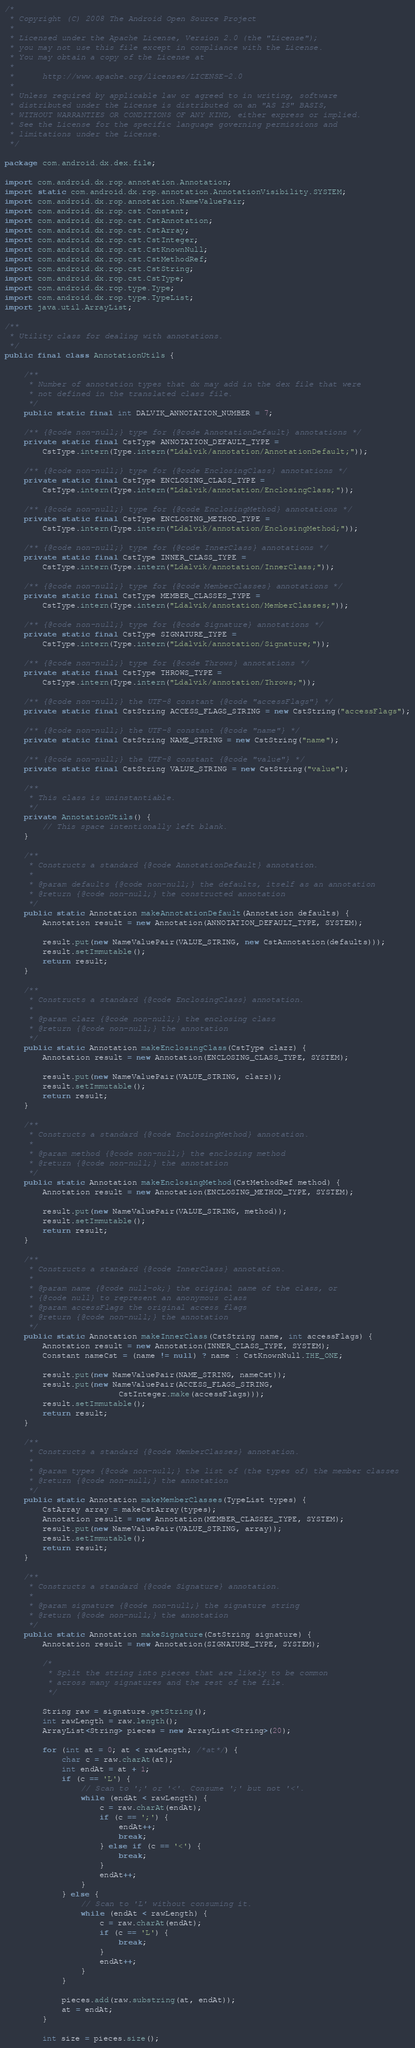Convert code to text. <code><loc_0><loc_0><loc_500><loc_500><_Java_>/*
 * Copyright (C) 2008 The Android Open Source Project
 *
 * Licensed under the Apache License, Version 2.0 (the "License");
 * you may not use this file except in compliance with the License.
 * You may obtain a copy of the License at
 *
 *      http://www.apache.org/licenses/LICENSE-2.0
 *
 * Unless required by applicable law or agreed to in writing, software
 * distributed under the License is distributed on an "AS IS" BASIS,
 * WITHOUT WARRANTIES OR CONDITIONS OF ANY KIND, either express or implied.
 * See the License for the specific language governing permissions and
 * limitations under the License.
 */

package com.android.dx.dex.file;

import com.android.dx.rop.annotation.Annotation;
import static com.android.dx.rop.annotation.AnnotationVisibility.SYSTEM;
import com.android.dx.rop.annotation.NameValuePair;
import com.android.dx.rop.cst.Constant;
import com.android.dx.rop.cst.CstAnnotation;
import com.android.dx.rop.cst.CstArray;
import com.android.dx.rop.cst.CstInteger;
import com.android.dx.rop.cst.CstKnownNull;
import com.android.dx.rop.cst.CstMethodRef;
import com.android.dx.rop.cst.CstString;
import com.android.dx.rop.cst.CstType;
import com.android.dx.rop.type.Type;
import com.android.dx.rop.type.TypeList;
import java.util.ArrayList;

/**
 * Utility class for dealing with annotations.
 */
public final class AnnotationUtils {

    /**
     * Number of annotation types that dx may add in the dex file that were
     * not defined in the translated class file.
     */
    public static final int DALVIK_ANNOTATION_NUMBER = 7;

    /** {@code non-null;} type for {@code AnnotationDefault} annotations */
    private static final CstType ANNOTATION_DEFAULT_TYPE =
        CstType.intern(Type.intern("Ldalvik/annotation/AnnotationDefault;"));

    /** {@code non-null;} type for {@code EnclosingClass} annotations */
    private static final CstType ENCLOSING_CLASS_TYPE =
        CstType.intern(Type.intern("Ldalvik/annotation/EnclosingClass;"));

    /** {@code non-null;} type for {@code EnclosingMethod} annotations */
    private static final CstType ENCLOSING_METHOD_TYPE =
        CstType.intern(Type.intern("Ldalvik/annotation/EnclosingMethod;"));

    /** {@code non-null;} type for {@code InnerClass} annotations */
    private static final CstType INNER_CLASS_TYPE =
        CstType.intern(Type.intern("Ldalvik/annotation/InnerClass;"));

    /** {@code non-null;} type for {@code MemberClasses} annotations */
    private static final CstType MEMBER_CLASSES_TYPE =
        CstType.intern(Type.intern("Ldalvik/annotation/MemberClasses;"));

    /** {@code non-null;} type for {@code Signature} annotations */
    private static final CstType SIGNATURE_TYPE =
        CstType.intern(Type.intern("Ldalvik/annotation/Signature;"));

    /** {@code non-null;} type for {@code Throws} annotations */
    private static final CstType THROWS_TYPE =
        CstType.intern(Type.intern("Ldalvik/annotation/Throws;"));

    /** {@code non-null;} the UTF-8 constant {@code "accessFlags"} */
    private static final CstString ACCESS_FLAGS_STRING = new CstString("accessFlags");

    /** {@code non-null;} the UTF-8 constant {@code "name"} */
    private static final CstString NAME_STRING = new CstString("name");

    /** {@code non-null;} the UTF-8 constant {@code "value"} */
    private static final CstString VALUE_STRING = new CstString("value");

    /**
     * This class is uninstantiable.
     */
    private AnnotationUtils() {
        // This space intentionally left blank.
    }

    /**
     * Constructs a standard {@code AnnotationDefault} annotation.
     *
     * @param defaults {@code non-null;} the defaults, itself as an annotation
     * @return {@code non-null;} the constructed annotation
     */
    public static Annotation makeAnnotationDefault(Annotation defaults) {
        Annotation result = new Annotation(ANNOTATION_DEFAULT_TYPE, SYSTEM);

        result.put(new NameValuePair(VALUE_STRING, new CstAnnotation(defaults)));
        result.setImmutable();
        return result;
    }

    /**
     * Constructs a standard {@code EnclosingClass} annotation.
     *
     * @param clazz {@code non-null;} the enclosing class
     * @return {@code non-null;} the annotation
     */
    public static Annotation makeEnclosingClass(CstType clazz) {
        Annotation result = new Annotation(ENCLOSING_CLASS_TYPE, SYSTEM);

        result.put(new NameValuePair(VALUE_STRING, clazz));
        result.setImmutable();
        return result;
    }

    /**
     * Constructs a standard {@code EnclosingMethod} annotation.
     *
     * @param method {@code non-null;} the enclosing method
     * @return {@code non-null;} the annotation
     */
    public static Annotation makeEnclosingMethod(CstMethodRef method) {
        Annotation result = new Annotation(ENCLOSING_METHOD_TYPE, SYSTEM);

        result.put(new NameValuePair(VALUE_STRING, method));
        result.setImmutable();
        return result;
    }

    /**
     * Constructs a standard {@code InnerClass} annotation.
     *
     * @param name {@code null-ok;} the original name of the class, or
     * {@code null} to represent an anonymous class
     * @param accessFlags the original access flags
     * @return {@code non-null;} the annotation
     */
    public static Annotation makeInnerClass(CstString name, int accessFlags) {
        Annotation result = new Annotation(INNER_CLASS_TYPE, SYSTEM);
        Constant nameCst = (name != null) ? name : CstKnownNull.THE_ONE;

        result.put(new NameValuePair(NAME_STRING, nameCst));
        result.put(new NameValuePair(ACCESS_FLAGS_STRING,
                        CstInteger.make(accessFlags)));
        result.setImmutable();
        return result;
    }

    /**
     * Constructs a standard {@code MemberClasses} annotation.
     *
     * @param types {@code non-null;} the list of (the types of) the member classes
     * @return {@code non-null;} the annotation
     */
    public static Annotation makeMemberClasses(TypeList types) {
        CstArray array = makeCstArray(types);
        Annotation result = new Annotation(MEMBER_CLASSES_TYPE, SYSTEM);
        result.put(new NameValuePair(VALUE_STRING, array));
        result.setImmutable();
        return result;
    }

    /**
     * Constructs a standard {@code Signature} annotation.
     *
     * @param signature {@code non-null;} the signature string
     * @return {@code non-null;} the annotation
     */
    public static Annotation makeSignature(CstString signature) {
        Annotation result = new Annotation(SIGNATURE_TYPE, SYSTEM);

        /*
         * Split the string into pieces that are likely to be common
         * across many signatures and the rest of the file.
         */

        String raw = signature.getString();
        int rawLength = raw.length();
        ArrayList<String> pieces = new ArrayList<String>(20);

        for (int at = 0; at < rawLength; /*at*/) {
            char c = raw.charAt(at);
            int endAt = at + 1;
            if (c == 'L') {
                // Scan to ';' or '<'. Consume ';' but not '<'.
                while (endAt < rawLength) {
                    c = raw.charAt(endAt);
                    if (c == ';') {
                        endAt++;
                        break;
                    } else if (c == '<') {
                        break;
                    }
                    endAt++;
                }
            } else {
                // Scan to 'L' without consuming it.
                while (endAt < rawLength) {
                    c = raw.charAt(endAt);
                    if (c == 'L') {
                        break;
                    }
                    endAt++;
                }
            }

            pieces.add(raw.substring(at, endAt));
            at = endAt;
        }

        int size = pieces.size();</code> 